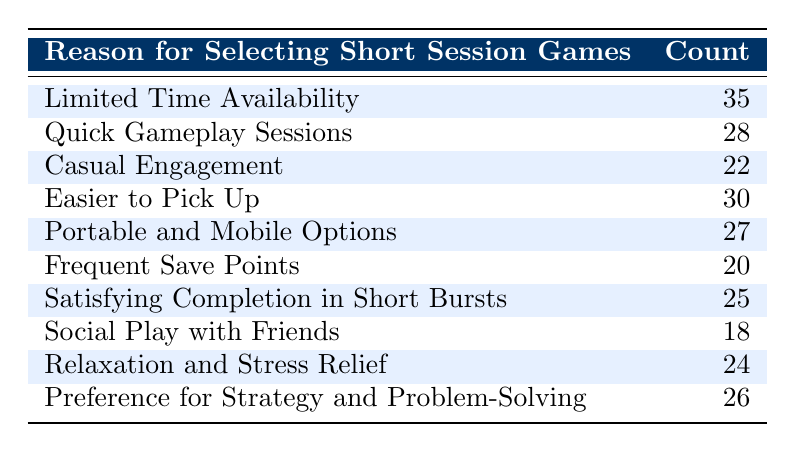What is the reason with the highest count for selecting short session games? The table shows various reasons for selecting short session games along with their respective counts. The highest count is 35, which corresponds to "Limited Time Availability."
Answer: Limited Time Availability What is the count for "Social Play with Friends"? By looking directly at the table, the count associated with "Social Play with Friends" is 18.
Answer: 18 What is the total count for the reasons related to casual engagement and relaxation? The table has counts for "Casual Engagement" (22) and "Relaxation and Stress Relief" (24). Summing these gives 22 + 24 = 46.
Answer: 46 Is "Frequent Save Points" the lowest counted reason? Looking at the counts in the table, "Frequent Save Points" has a count of 20, which is lower than all other reasons listed. Therefore, it is true that it is the lowest.
Answer: Yes What is the difference in count between "Quick Gameplay Sessions" and "Easier to Pick Up"? The count for "Quick Gameplay Sessions" is 28, and for "Easier to Pick Up," it is 30. Thus, the difference is 30 - 28 = 2.
Answer: 2 What is the average count of the reasons that include "Portable" and "Quick"? "Portable and Mobile Options" has a count of 27 and "Quick Gameplay Sessions" has a count of 28. The average is calculated as (27 + 28) / 2 = 27.5.
Answer: 27.5 Are there more reasons related to strategy and problem-solving than relaxation? The count for "Preference for Strategy and Problem-Solving" is 26, while "Relaxation and Stress Relief" has a count of 24. Since 26 is greater than 24, the statement is true.
Answer: Yes What percentage of casual gamers select "Limited Time Availability" compared to total counts? The total count of all reasons is 35 + 28 + 22 + 30 + 27 + 20 + 25 + 18 + 24 + 26 =  35 + 28 + 22 + 30 + 27 + 20 + 25 + 18 + 24 + 26 =  235. The percentage for "Limited Time Availability" is (35 / 235) * 100 = 14.89%, approximately 15%.
Answer: 15% What are the two reasons that have counts closest to each other? The counts for "Relaxation and Stress Relief" (24) and "Satisfying Completion in Short Bursts" (25) are very close together, differing by just 1.
Answer: Relaxation and Stress Relief, Satisfying Completion in Short Bursts 